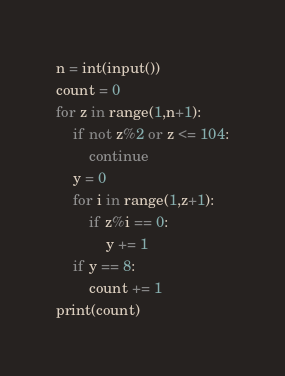Convert code to text. <code><loc_0><loc_0><loc_500><loc_500><_Python_>n = int(input())
count = 0
for z in range(1,n+1):
	if not z%2 or z <= 104:
		continue
	y = 0
	for i in range(1,z+1):
		if z%i == 0:
			y += 1	
	if y == 8:
		count += 1
print(count)	
</code> 